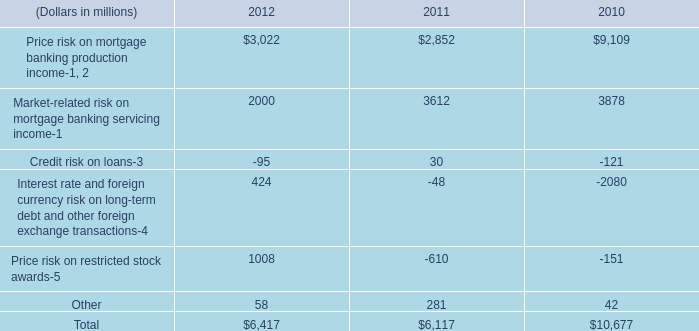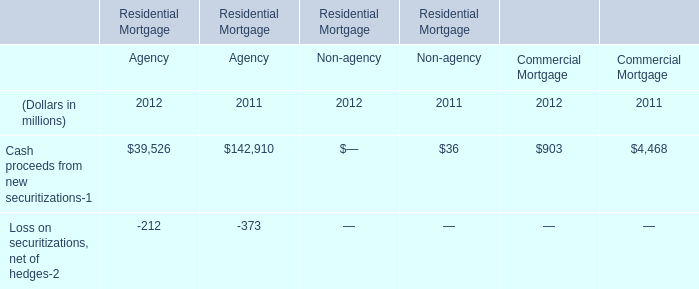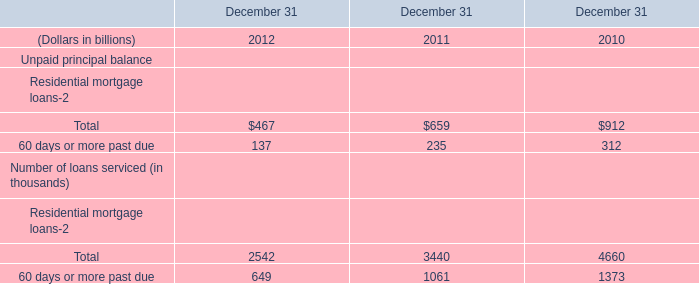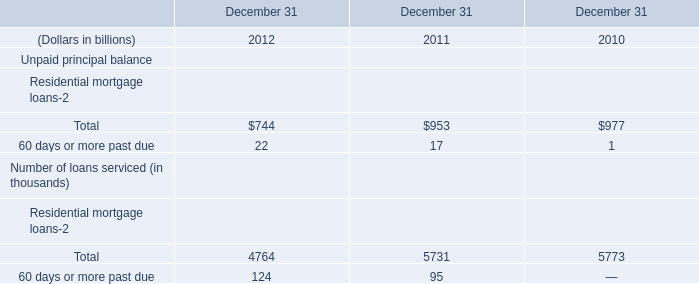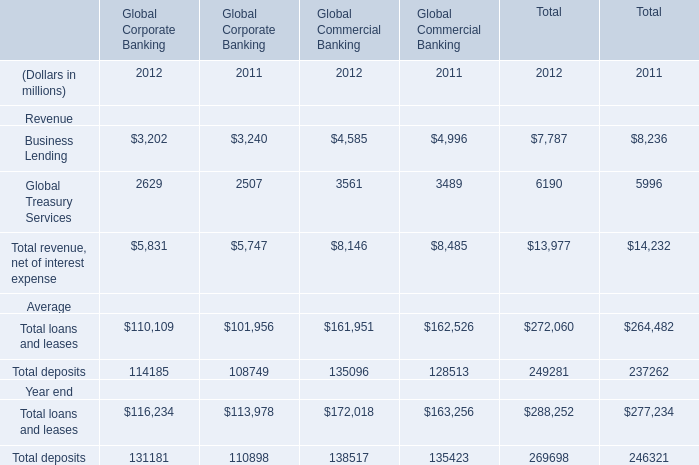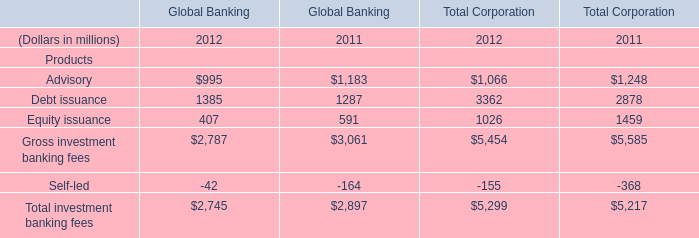What's the current increasing rate of Debt issuance of Global Banking? 
Computations: ((1385 - 1287) / 1287)
Answer: 0.07615. 